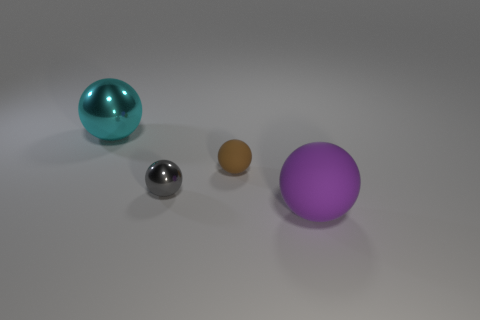Subtract all purple balls. How many balls are left? 3 Subtract all purple balls. How many balls are left? 3 Subtract 1 spheres. How many spheres are left? 3 Subtract all blue balls. Subtract all blue cylinders. How many balls are left? 4 Add 1 gray spheres. How many objects exist? 5 Add 4 shiny balls. How many shiny balls exist? 6 Subtract 0 gray cylinders. How many objects are left? 4 Subtract all large spheres. Subtract all tiny balls. How many objects are left? 0 Add 4 small objects. How many small objects are left? 6 